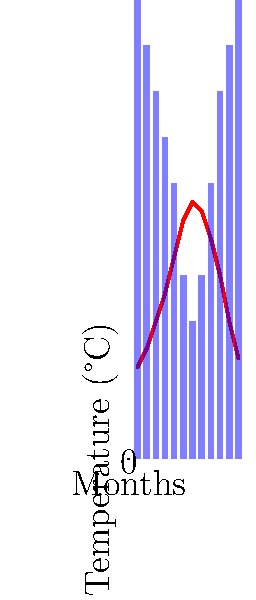Based on the temperature and rainfall chart for a vineyard, during which month would you typically begin harvesting grapes for a full-bodied red wine? To determine the optimal grape harvesting time for a full-bodied red wine, we need to consider several factors:

1. Temperature: Red wine grapes typically reach optimal ripeness when daytime temperatures are between 20°C and 30°C.

2. Rainfall: Less rainfall is preferred during the ripening period to concentrate flavors and sugars in the grapes.

3. Grape variety: Full-bodied red wines often require longer ripening periods.

Analyzing the chart:

1. Temperature peaks in July (month 7) at 28°C and starts declining afterwards.

2. Rainfall is lowest in July and starts increasing from August (month 8).

3. For full-bodied reds, we want to allow for a longer ripening period, so we'd typically harvest later than for lighter wines.

4. September (month 9) shows a good balance:
   - Temperature is still high (24°C), promoting sugar development.
   - Rainfall is increasing but still relatively low, helping to concentrate flavors.
   - It's late enough in the season for full-bodied red grapes to develop complex flavors.

Therefore, September (month 9) would typically be the ideal month to begin harvesting grapes for a full-bodied red wine.
Answer: September 